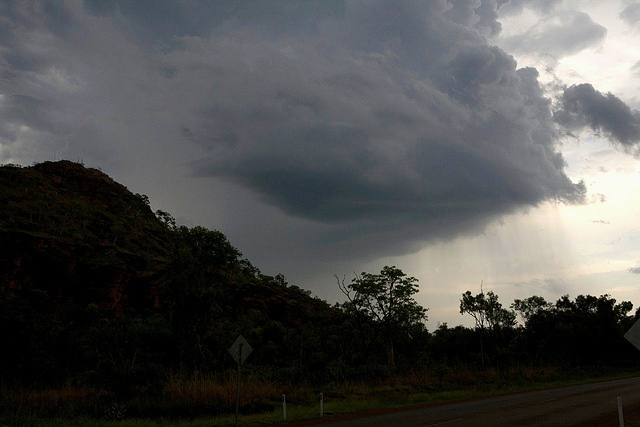Describe the objects in this image and their specific colors. I can see various objects in this image with different colors. 